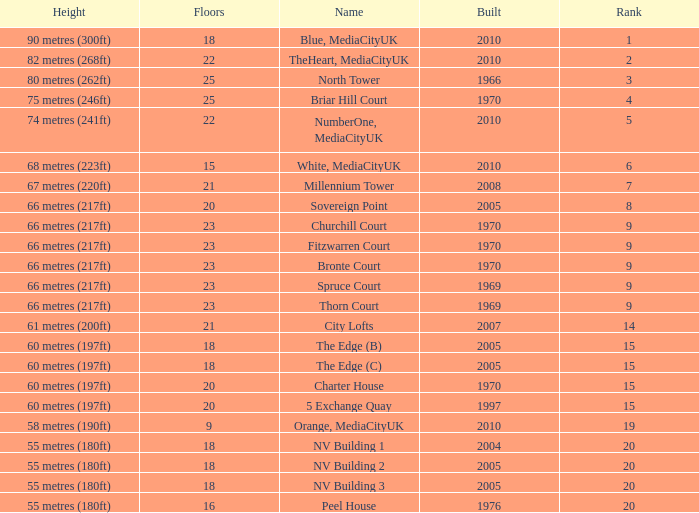What is the lowest Built, when Floors is greater than 23, and when Rank is 3? 1966.0. 